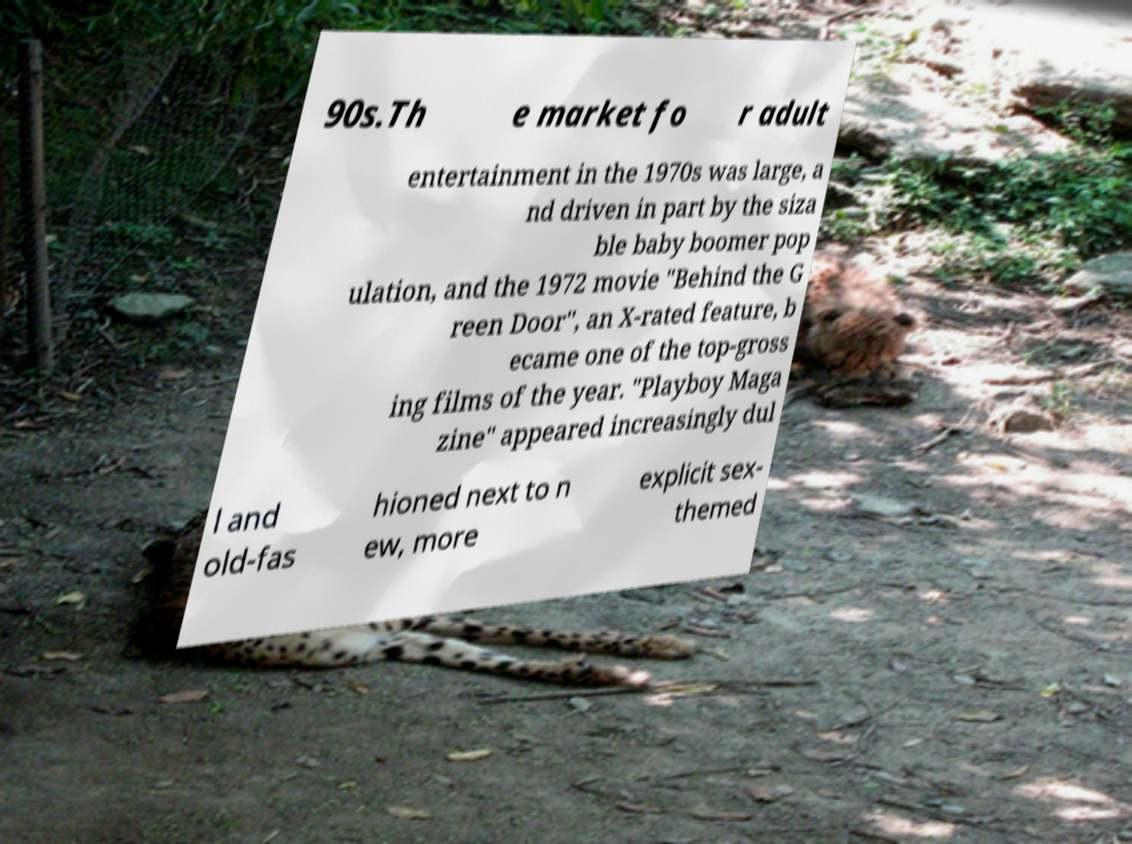What messages or text are displayed in this image? I need them in a readable, typed format. 90s.Th e market fo r adult entertainment in the 1970s was large, a nd driven in part by the siza ble baby boomer pop ulation, and the 1972 movie "Behind the G reen Door", an X-rated feature, b ecame one of the top-gross ing films of the year. "Playboy Maga zine" appeared increasingly dul l and old-fas hioned next to n ew, more explicit sex- themed 